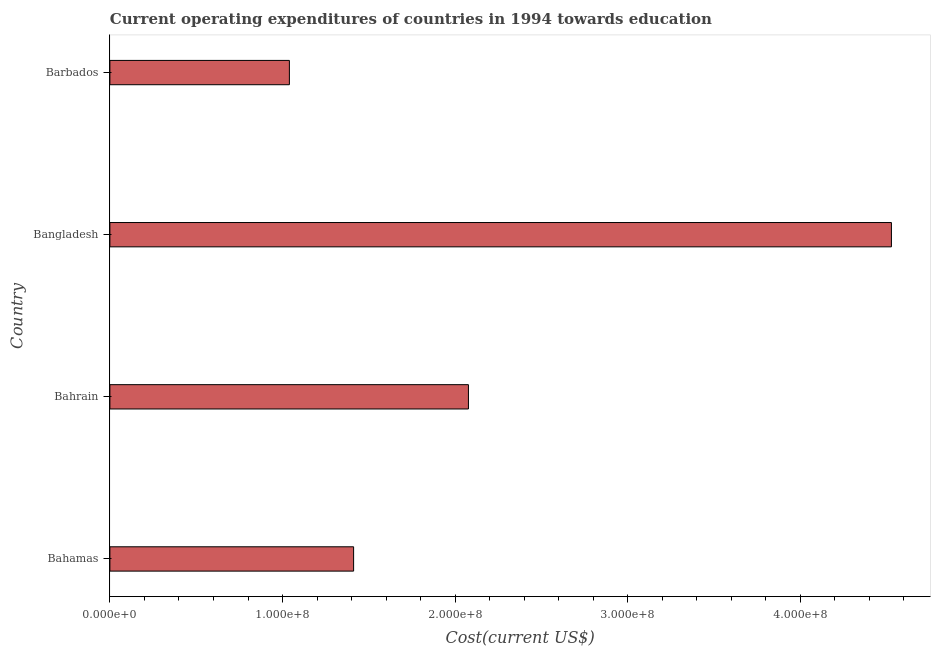Does the graph contain any zero values?
Offer a very short reply. No. Does the graph contain grids?
Offer a very short reply. No. What is the title of the graph?
Provide a short and direct response. Current operating expenditures of countries in 1994 towards education. What is the label or title of the X-axis?
Make the answer very short. Cost(current US$). What is the education expenditure in Barbados?
Give a very brief answer. 1.04e+08. Across all countries, what is the maximum education expenditure?
Your answer should be compact. 4.53e+08. Across all countries, what is the minimum education expenditure?
Provide a short and direct response. 1.04e+08. In which country was the education expenditure minimum?
Offer a terse response. Barbados. What is the sum of the education expenditure?
Make the answer very short. 9.06e+08. What is the difference between the education expenditure in Bahrain and Barbados?
Make the answer very short. 1.04e+08. What is the average education expenditure per country?
Your answer should be compact. 2.26e+08. What is the median education expenditure?
Offer a terse response. 1.74e+08. In how many countries, is the education expenditure greater than 340000000 US$?
Your answer should be compact. 1. What is the ratio of the education expenditure in Bahrain to that in Bangladesh?
Provide a short and direct response. 0.46. Is the education expenditure in Bahamas less than that in Barbados?
Give a very brief answer. No. What is the difference between the highest and the second highest education expenditure?
Offer a terse response. 2.45e+08. What is the difference between the highest and the lowest education expenditure?
Give a very brief answer. 3.49e+08. How many bars are there?
Offer a terse response. 4. What is the difference between two consecutive major ticks on the X-axis?
Give a very brief answer. 1.00e+08. What is the Cost(current US$) in Bahamas?
Your answer should be compact. 1.41e+08. What is the Cost(current US$) of Bahrain?
Make the answer very short. 2.08e+08. What is the Cost(current US$) in Bangladesh?
Your answer should be compact. 4.53e+08. What is the Cost(current US$) in Barbados?
Your response must be concise. 1.04e+08. What is the difference between the Cost(current US$) in Bahamas and Bahrain?
Offer a terse response. -6.65e+07. What is the difference between the Cost(current US$) in Bahamas and Bangladesh?
Offer a terse response. -3.12e+08. What is the difference between the Cost(current US$) in Bahamas and Barbados?
Your answer should be compact. 3.72e+07. What is the difference between the Cost(current US$) in Bahrain and Bangladesh?
Keep it short and to the point. -2.45e+08. What is the difference between the Cost(current US$) in Bahrain and Barbados?
Ensure brevity in your answer.  1.04e+08. What is the difference between the Cost(current US$) in Bangladesh and Barbados?
Provide a short and direct response. 3.49e+08. What is the ratio of the Cost(current US$) in Bahamas to that in Bahrain?
Offer a terse response. 0.68. What is the ratio of the Cost(current US$) in Bahamas to that in Bangladesh?
Give a very brief answer. 0.31. What is the ratio of the Cost(current US$) in Bahamas to that in Barbados?
Your response must be concise. 1.36. What is the ratio of the Cost(current US$) in Bahrain to that in Bangladesh?
Your response must be concise. 0.46. What is the ratio of the Cost(current US$) in Bahrain to that in Barbados?
Ensure brevity in your answer.  2. What is the ratio of the Cost(current US$) in Bangladesh to that in Barbados?
Give a very brief answer. 4.35. 